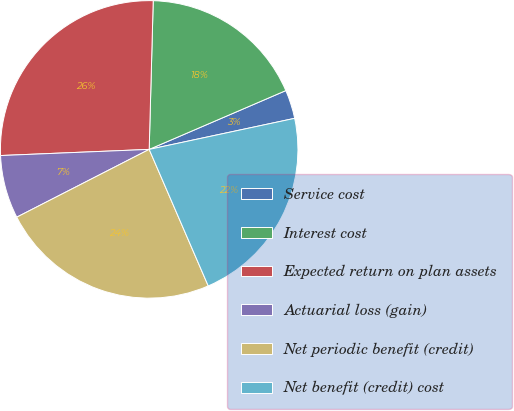Convert chart. <chart><loc_0><loc_0><loc_500><loc_500><pie_chart><fcel>Service cost<fcel>Interest cost<fcel>Expected return on plan assets<fcel>Actuarial loss (gain)<fcel>Net periodic benefit (credit)<fcel>Net benefit (credit) cost<nl><fcel>3.12%<fcel>18.1%<fcel>26.09%<fcel>6.87%<fcel>23.97%<fcel>21.85%<nl></chart> 